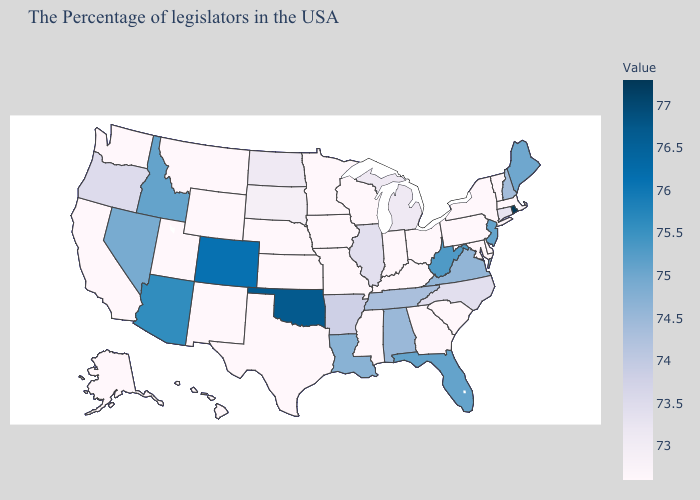Does Oregon have a lower value than Indiana?
Concise answer only. No. Which states have the lowest value in the West?
Answer briefly. Wyoming, New Mexico, Utah, Montana, California, Washington, Alaska, Hawaii. Is the legend a continuous bar?
Concise answer only. Yes. 